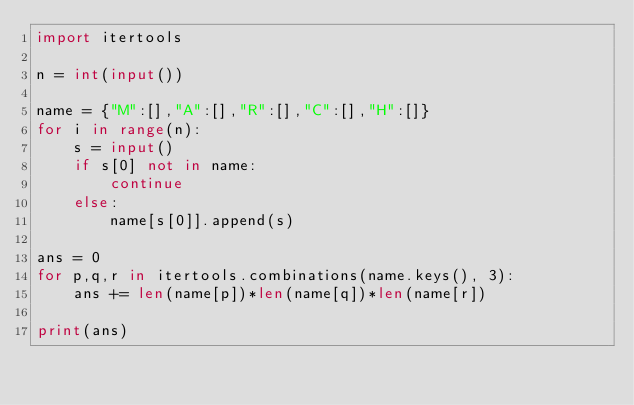<code> <loc_0><loc_0><loc_500><loc_500><_Python_>import itertools

n = int(input())

name = {"M":[],"A":[],"R":[],"C":[],"H":[]}
for i in range(n):
    s = input()
    if s[0] not in name:
        continue
    else:
        name[s[0]].append(s)

ans = 0
for p,q,r in itertools.combinations(name.keys(), 3):
    ans += len(name[p])*len(name[q])*len(name[r])
    
print(ans)</code> 